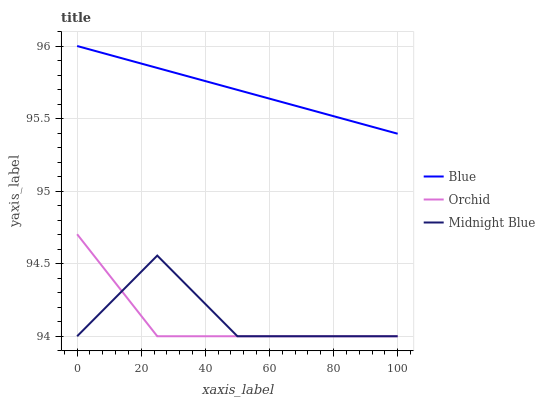Does Midnight Blue have the minimum area under the curve?
Answer yes or no. No. Does Midnight Blue have the maximum area under the curve?
Answer yes or no. No. Is Orchid the smoothest?
Answer yes or no. No. Is Orchid the roughest?
Answer yes or no. No. Does Orchid have the highest value?
Answer yes or no. No. Is Midnight Blue less than Blue?
Answer yes or no. Yes. Is Blue greater than Midnight Blue?
Answer yes or no. Yes. Does Midnight Blue intersect Blue?
Answer yes or no. No. 